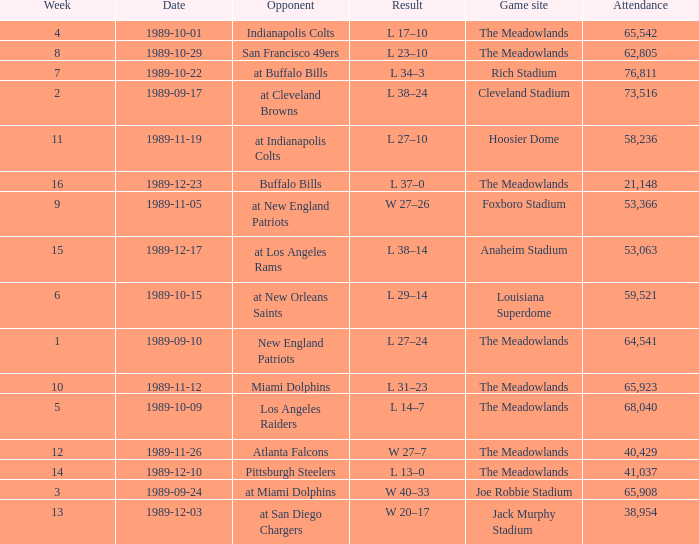What day did they play before week 2? 1989-09-10. 